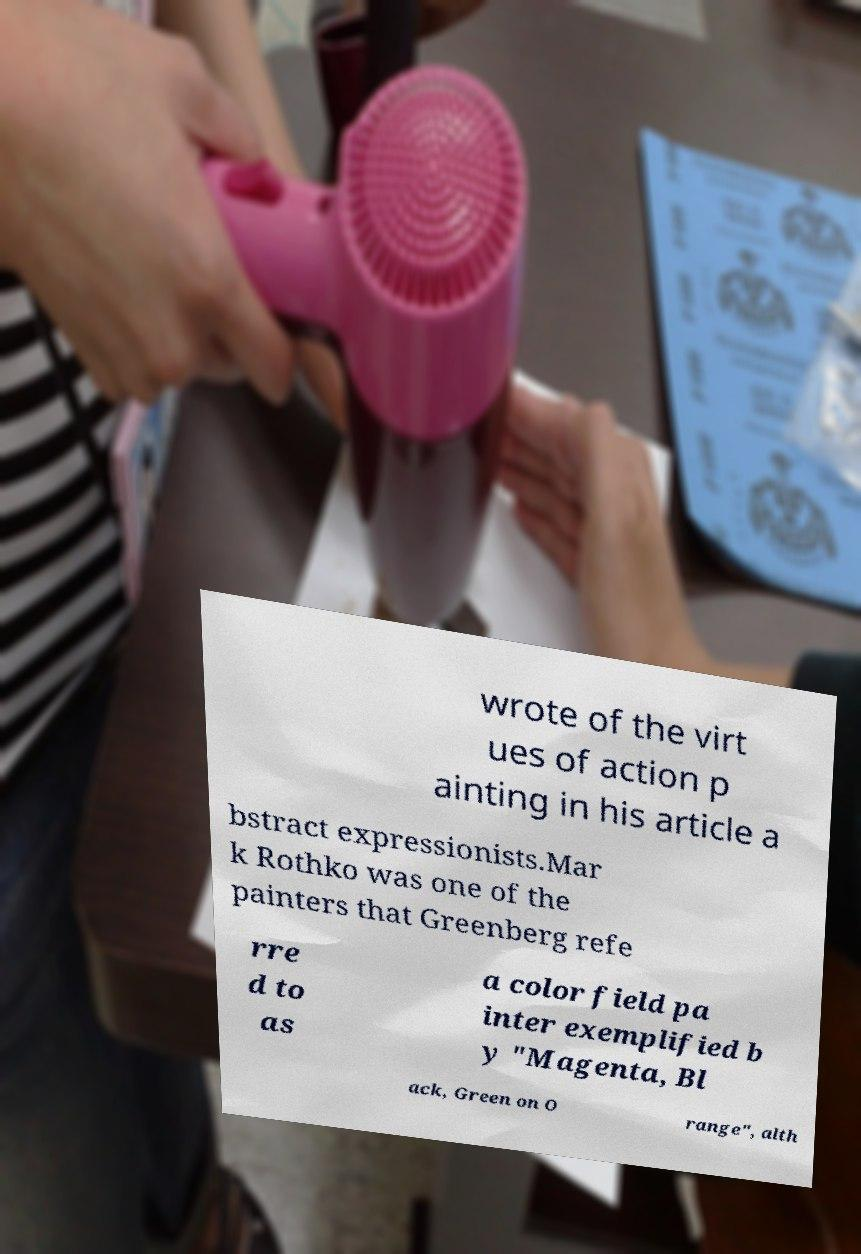For documentation purposes, I need the text within this image transcribed. Could you provide that? wrote of the virt ues of action p ainting in his article a bstract expressionists.Mar k Rothko was one of the painters that Greenberg refe rre d to as a color field pa inter exemplified b y "Magenta, Bl ack, Green on O range", alth 